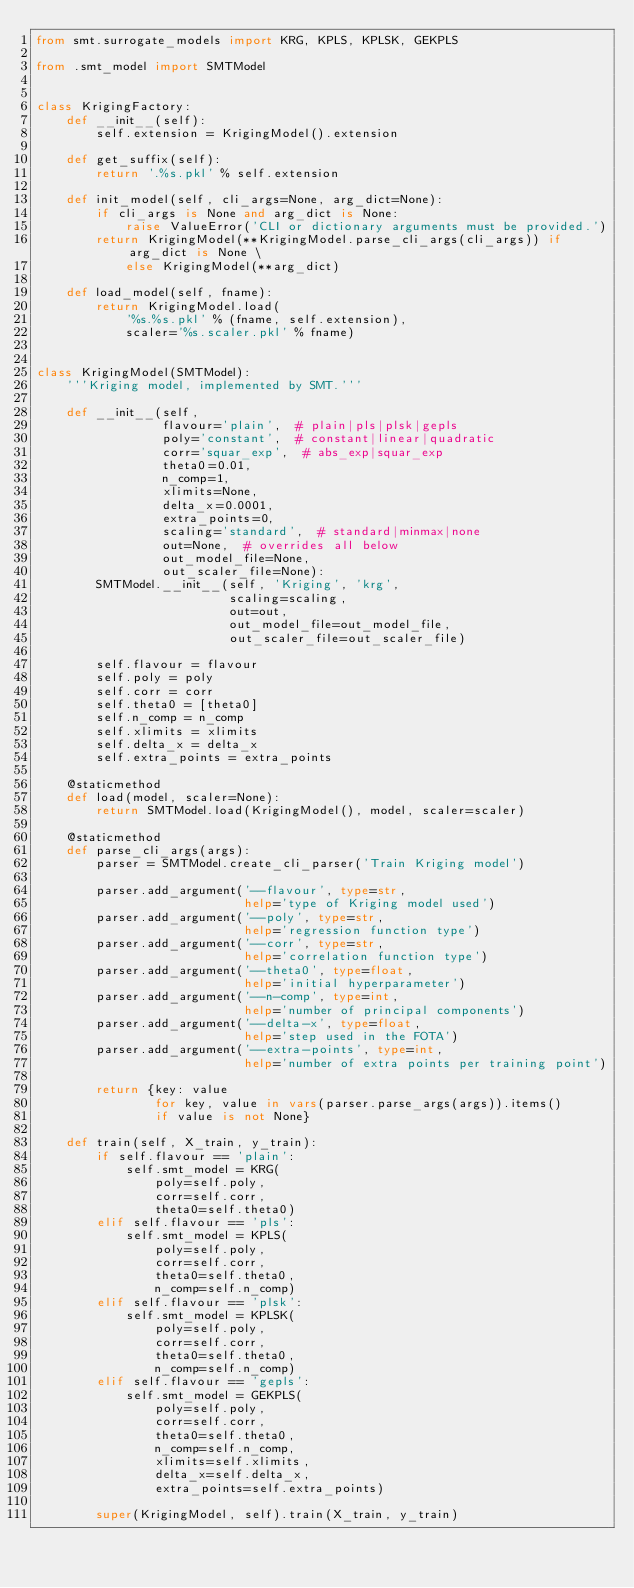Convert code to text. <code><loc_0><loc_0><loc_500><loc_500><_Python_>from smt.surrogate_models import KRG, KPLS, KPLSK, GEKPLS

from .smt_model import SMTModel


class KrigingFactory:
    def __init__(self):
        self.extension = KrigingModel().extension

    def get_suffix(self):
        return '.%s.pkl' % self.extension

    def init_model(self, cli_args=None, arg_dict=None):
        if cli_args is None and arg_dict is None:
            raise ValueError('CLI or dictionary arguments must be provided.')
        return KrigingModel(**KrigingModel.parse_cli_args(cli_args)) if arg_dict is None \
            else KrigingModel(**arg_dict)

    def load_model(self, fname):
        return KrigingModel.load(
            '%s.%s.pkl' % (fname, self.extension),
            scaler='%s.scaler.pkl' % fname)


class KrigingModel(SMTModel):
    '''Kriging model, implemented by SMT.'''

    def __init__(self,
                 flavour='plain',  # plain|pls|plsk|gepls
                 poly='constant',  # constant|linear|quadratic
                 corr='squar_exp',  # abs_exp|squar_exp
                 theta0=0.01,
                 n_comp=1,
                 xlimits=None,
                 delta_x=0.0001,
                 extra_points=0,
                 scaling='standard',  # standard|minmax|none
                 out=None,  # overrides all below
                 out_model_file=None,
                 out_scaler_file=None):
        SMTModel.__init__(self, 'Kriging', 'krg',
                          scaling=scaling,
                          out=out,
                          out_model_file=out_model_file,
                          out_scaler_file=out_scaler_file)

        self.flavour = flavour
        self.poly = poly
        self.corr = corr
        self.theta0 = [theta0]
        self.n_comp = n_comp
        self.xlimits = xlimits
        self.delta_x = delta_x
        self.extra_points = extra_points

    @staticmethod
    def load(model, scaler=None):
        return SMTModel.load(KrigingModel(), model, scaler=scaler)

    @staticmethod
    def parse_cli_args(args):
        parser = SMTModel.create_cli_parser('Train Kriging model')

        parser.add_argument('--flavour', type=str,
                            help='type of Kriging model used')
        parser.add_argument('--poly', type=str,
                            help='regression function type')
        parser.add_argument('--corr', type=str,
                            help='correlation function type')
        parser.add_argument('--theta0', type=float,
                            help='initial hyperparameter')
        parser.add_argument('--n-comp', type=int,
                            help='number of principal components')
        parser.add_argument('--delta-x', type=float,
                            help='step used in the FOTA')
        parser.add_argument('--extra-points', type=int,
                            help='number of extra points per training point')

        return {key: value
                for key, value in vars(parser.parse_args(args)).items()
                if value is not None}

    def train(self, X_train, y_train):
        if self.flavour == 'plain':
            self.smt_model = KRG(
                poly=self.poly,
                corr=self.corr,
                theta0=self.theta0)
        elif self.flavour == 'pls':
            self.smt_model = KPLS(
                poly=self.poly,
                corr=self.corr,
                theta0=self.theta0,
                n_comp=self.n_comp)
        elif self.flavour == 'plsk':
            self.smt_model = KPLSK(
                poly=self.poly,
                corr=self.corr,
                theta0=self.theta0,
                n_comp=self.n_comp)
        elif self.flavour == 'gepls':
            self.smt_model = GEKPLS(
                poly=self.poly,
                corr=self.corr,
                theta0=self.theta0,
                n_comp=self.n_comp,
                xlimits=self.xlimits,
                delta_x=self.delta_x,
                extra_points=self.extra_points)

        super(KrigingModel, self).train(X_train, y_train)
</code> 